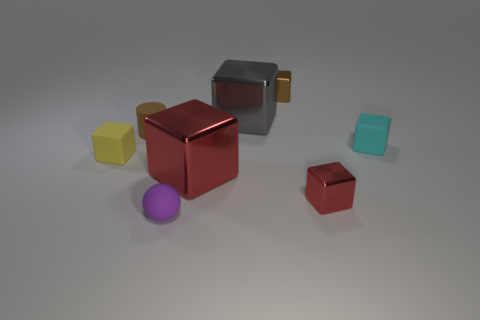Subtract all gray spheres. How many red blocks are left? 2 Subtract all tiny red shiny cubes. How many cubes are left? 5 Subtract all gray cubes. How many cubes are left? 5 Subtract all yellow blocks. Subtract all red spheres. How many blocks are left? 5 Add 1 tiny purple rubber blocks. How many objects exist? 9 Subtract all balls. How many objects are left? 7 Add 7 brown cylinders. How many brown cylinders exist? 8 Subtract 1 gray blocks. How many objects are left? 7 Subtract all large red blocks. Subtract all large gray metallic objects. How many objects are left? 6 Add 5 tiny shiny blocks. How many tiny shiny blocks are left? 7 